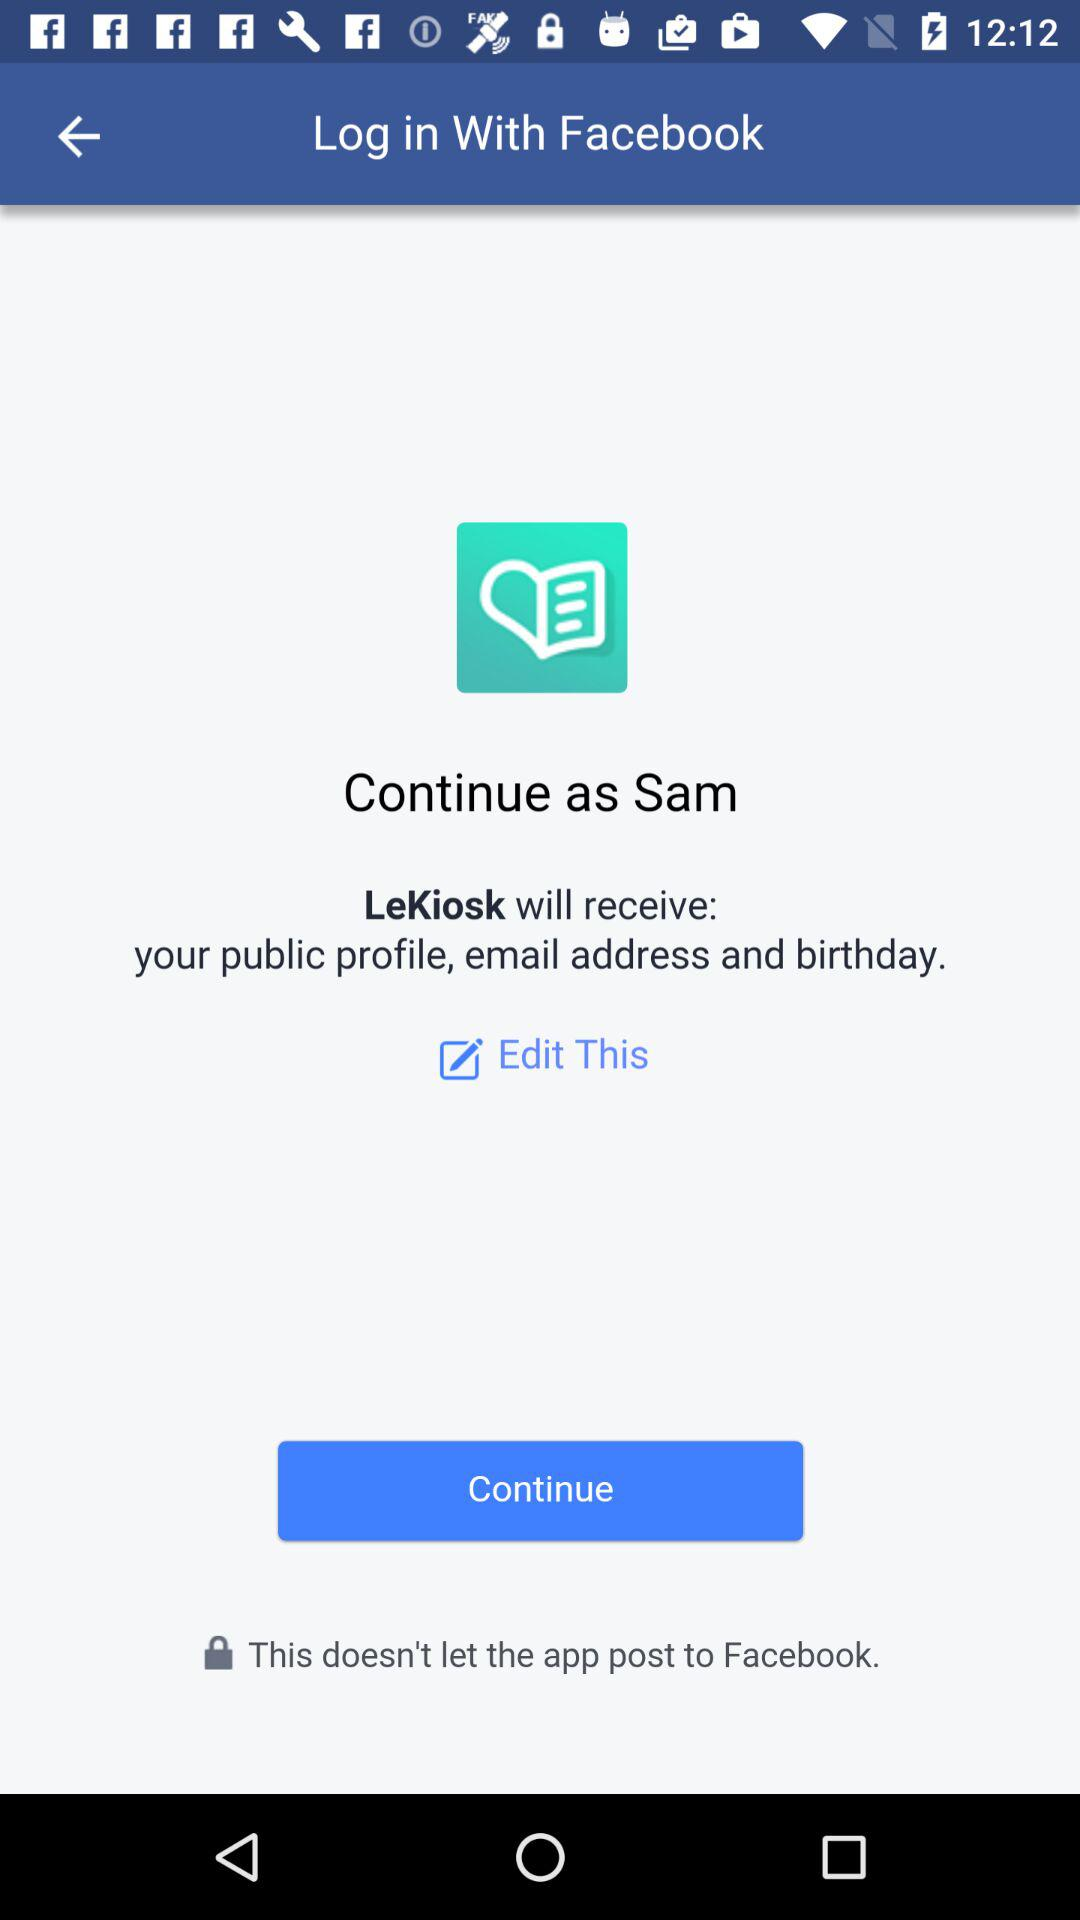Which option is selected?
When the provided information is insufficient, respond with <no answer>. <no answer> 